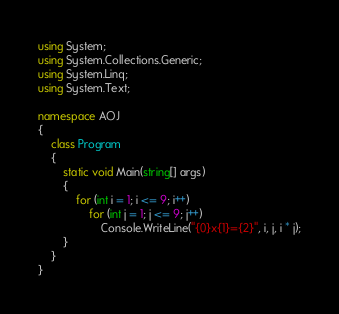Convert code to text. <code><loc_0><loc_0><loc_500><loc_500><_C#_>using System;
using System.Collections.Generic;
using System.Linq;
using System.Text;

namespace AOJ
{
	class Program
	{
		static void Main(string[] args)
		{
			for (int i = 1; i <= 9; i++)
				for (int j = 1; j <= 9; j++)
					Console.WriteLine("{0}x{1}={2}", i, j, i * j);
		}
	}
}</code> 